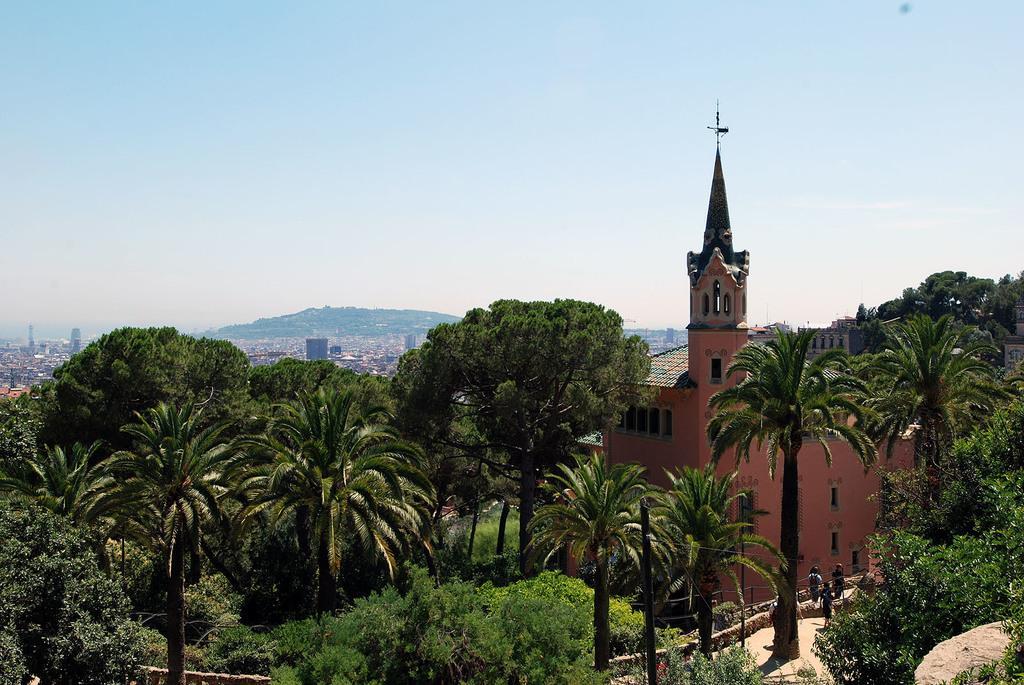Please provide a concise description of this image. In this picture we can see a building and in front of the building there are trees and poles. Behind the building, those are looking like houses. Behind the houses there is a hill and the sky. 